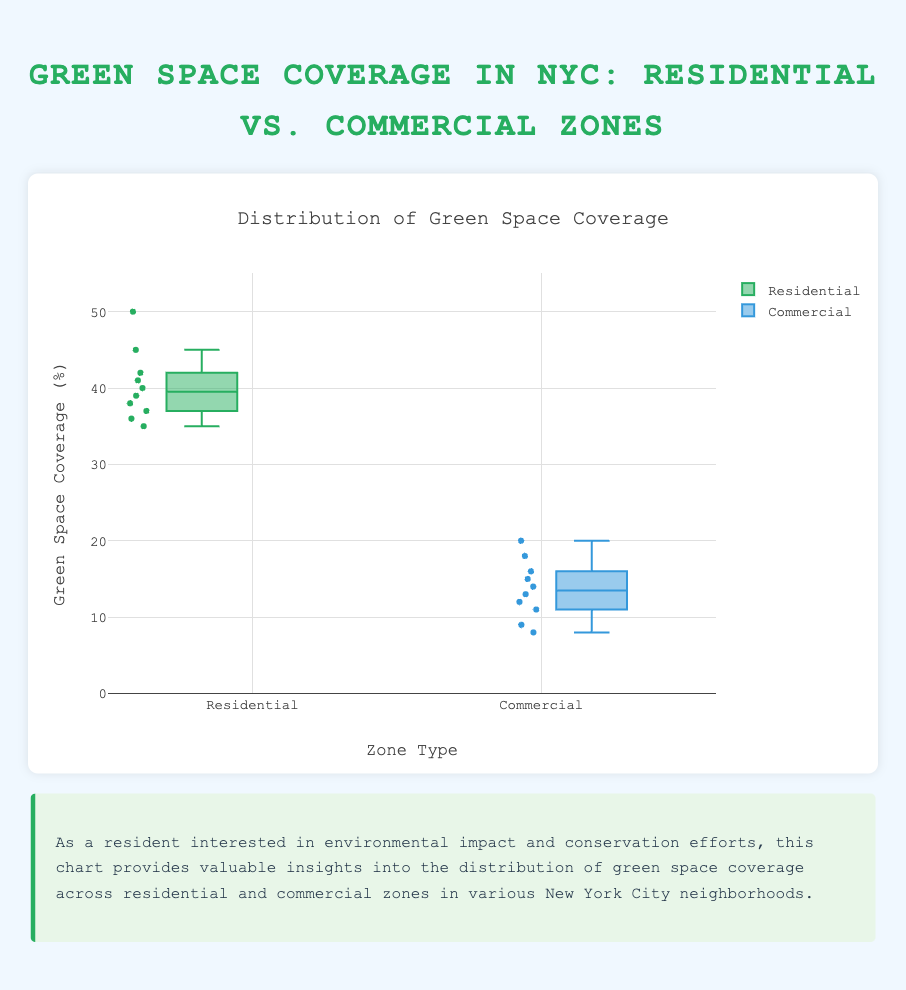What is the title of the plot? The title is displayed at the top of the chart, serving as a summary of what the figure represents. It reads, "Distribution of Green Space Coverage."
Answer: Distribution of Green Space Coverage What is the median green space coverage percentage for residential zones? To find the median, locate the middle value in the box of the residential zone's box plot. The median is shown as a line across the box.
Answer: 39 Which zone type has a higher median green space coverage percentage? Comparing the median lines in both box plots, we see that the median for residential zones is higher than that for commercial zones.
Answer: Residential What is the range of green space coverage in commercial zones? The range is calculated by subtracting the minimum value from the maximum value in the commercial zone's box plot. The minimum is around 8%, and the maximum is around 20%.
Answer: 12% How do the spreads of green space coverage compare between residential and commercial zones? The spread (range) for residential zones is from the bottom of the whisker to the top: approximately 35% to 50%. For commercial zones, it is from 8% to 20%. The residential zone spread is much larger.
Answer: Residential zones have a larger spread Which residential neighborhood has the highest green space coverage? By hovering over the markers in the residential box plot, we can find the neighborhood with the highest green space coverage percentage: Midtown at 50%.
Answer: Midtown Are there any outliers in the commercial zones' green space coverage? In box plots, outliers are typically shown as points outside the whiskers. By inspecting the commercial box plot, we see no points outside the whiskers.
Answer: No What is the interquartile range (IQR) for green space coverage in residential zones? The IQR is found by subtracting the first quartile value (Q1) from the third quartile value (Q3). For residential zones, it's approximately 37% (Q1) to 42% (Q3).
Answer: 5% Which neighborhood occupies the median percentage point for green space coverage in commercial zones? By examining the commercial box plot and identifying the median value, we hover over the median marker to see which neighborhood it corresponds to: Flatiron District at 16%.
Answer: Flatiron District 